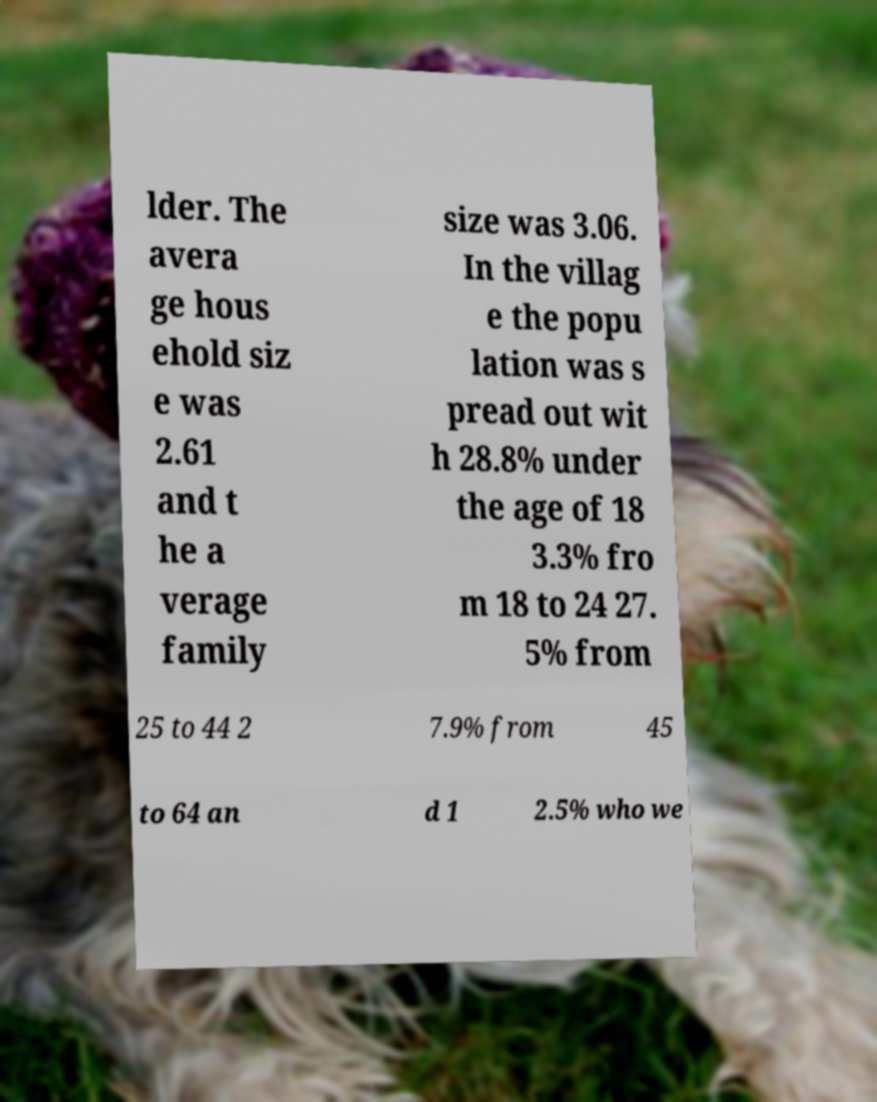Can you read and provide the text displayed in the image?This photo seems to have some interesting text. Can you extract and type it out for me? lder. The avera ge hous ehold siz e was 2.61 and t he a verage family size was 3.06. In the villag e the popu lation was s pread out wit h 28.8% under the age of 18 3.3% fro m 18 to 24 27. 5% from 25 to 44 2 7.9% from 45 to 64 an d 1 2.5% who we 